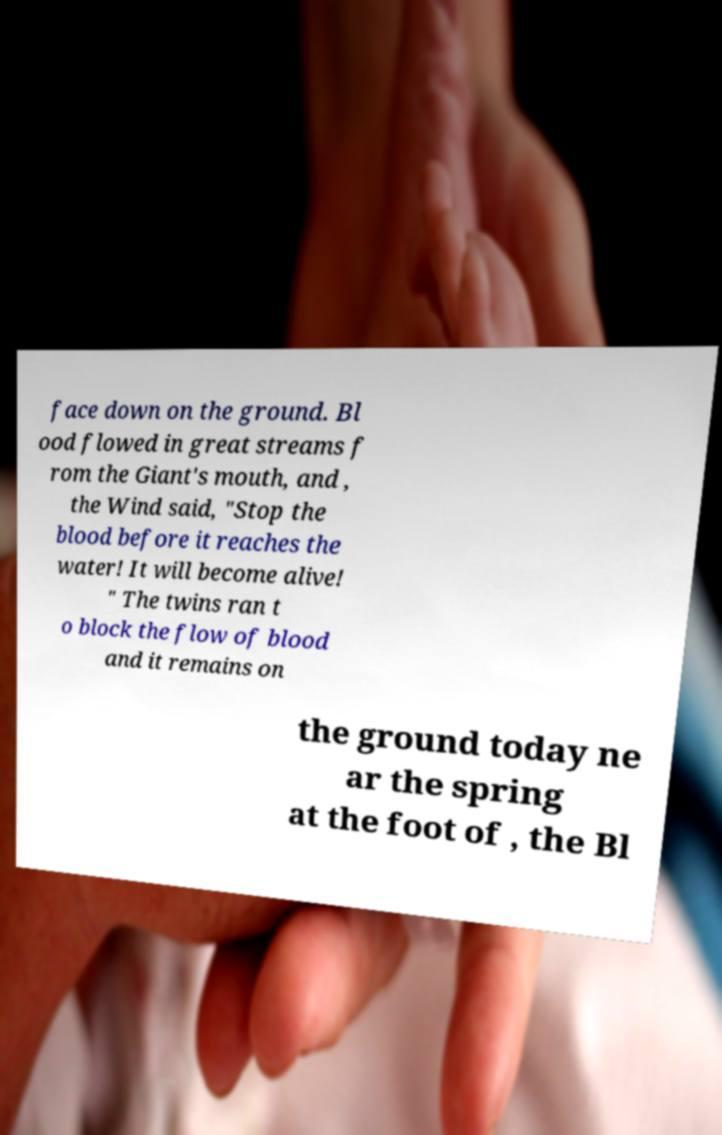For documentation purposes, I need the text within this image transcribed. Could you provide that? face down on the ground. Bl ood flowed in great streams f rom the Giant's mouth, and , the Wind said, "Stop the blood before it reaches the water! It will become alive! " The twins ran t o block the flow of blood and it remains on the ground today ne ar the spring at the foot of , the Bl 